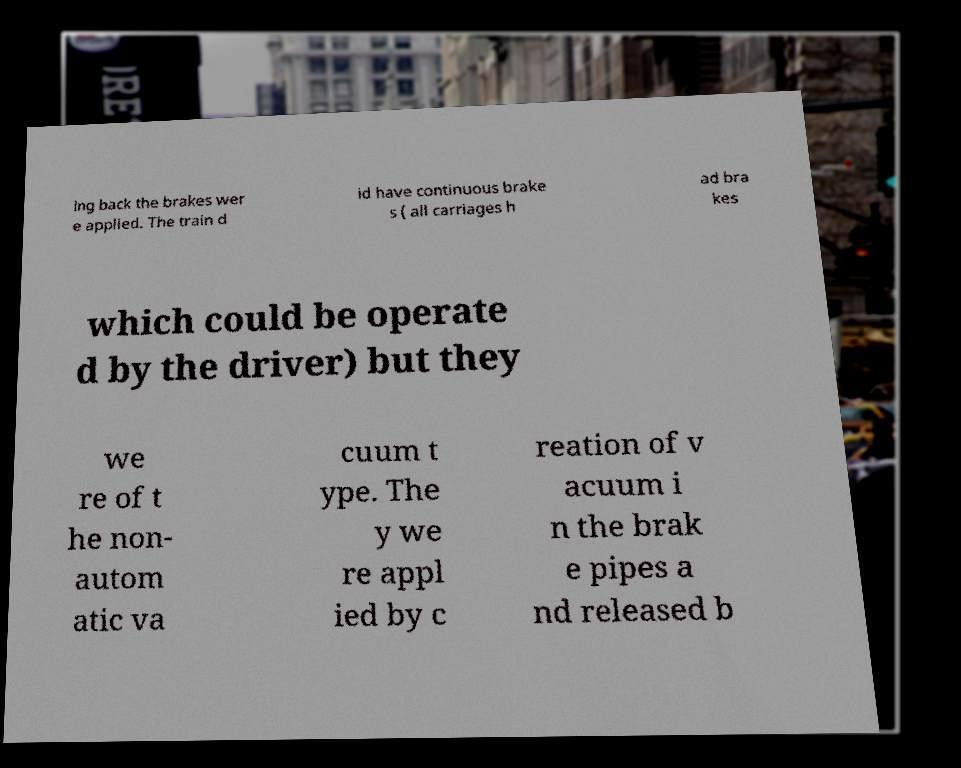Please read and relay the text visible in this image. What does it say? ing back the brakes wer e applied. The train d id have continuous brake s ( all carriages h ad bra kes which could be operate d by the driver) but they we re of t he non- autom atic va cuum t ype. The y we re appl ied by c reation of v acuum i n the brak e pipes a nd released b 